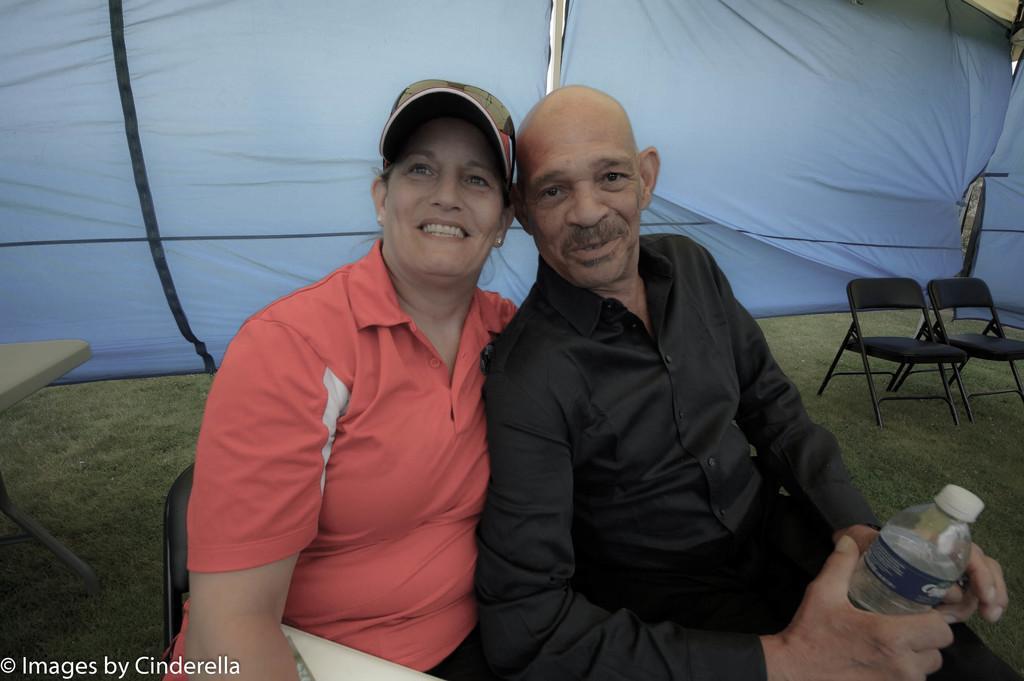Describe this image in one or two sentences. In this picture we can see a woman and a man sitting on the chairs. She wear a cap and he is holding a bottle with his hands. This is grass and there is a table. 